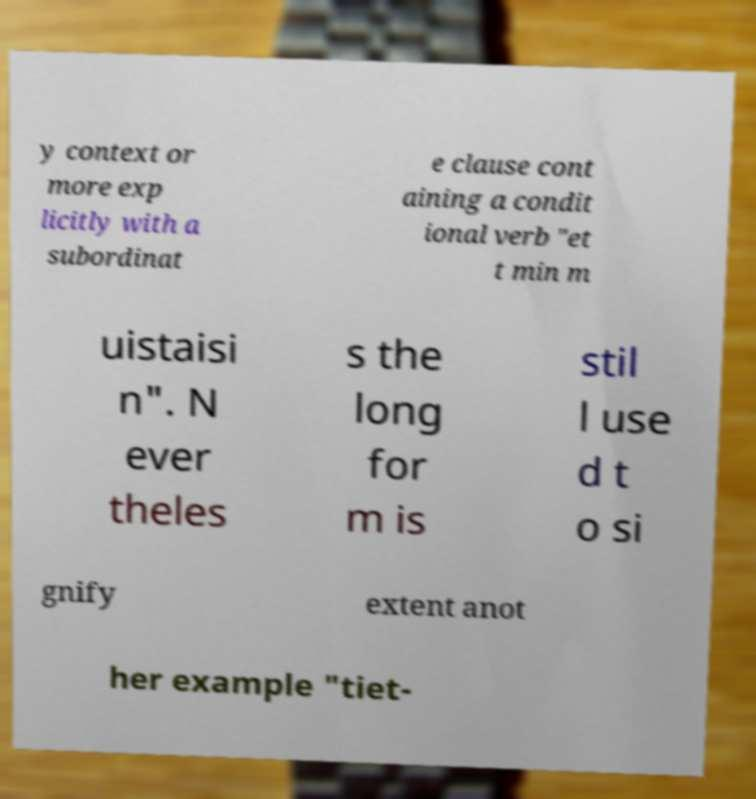What messages or text are displayed in this image? I need them in a readable, typed format. y context or more exp licitly with a subordinat e clause cont aining a condit ional verb "et t min m uistaisi n". N ever theles s the long for m is stil l use d t o si gnify extent anot her example "tiet- 